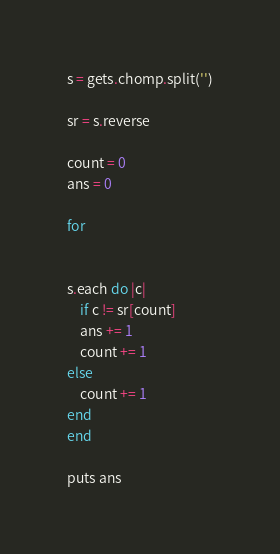Convert code to text. <code><loc_0><loc_0><loc_500><loc_500><_Ruby_>s = gets.chomp.split('')

sr = s.reverse

count = 0
ans = 0

for 


s.each do |c|
	if c != sr[count]
	ans += 1
	count += 1
else
	count += 1
end
end

puts ans</code> 